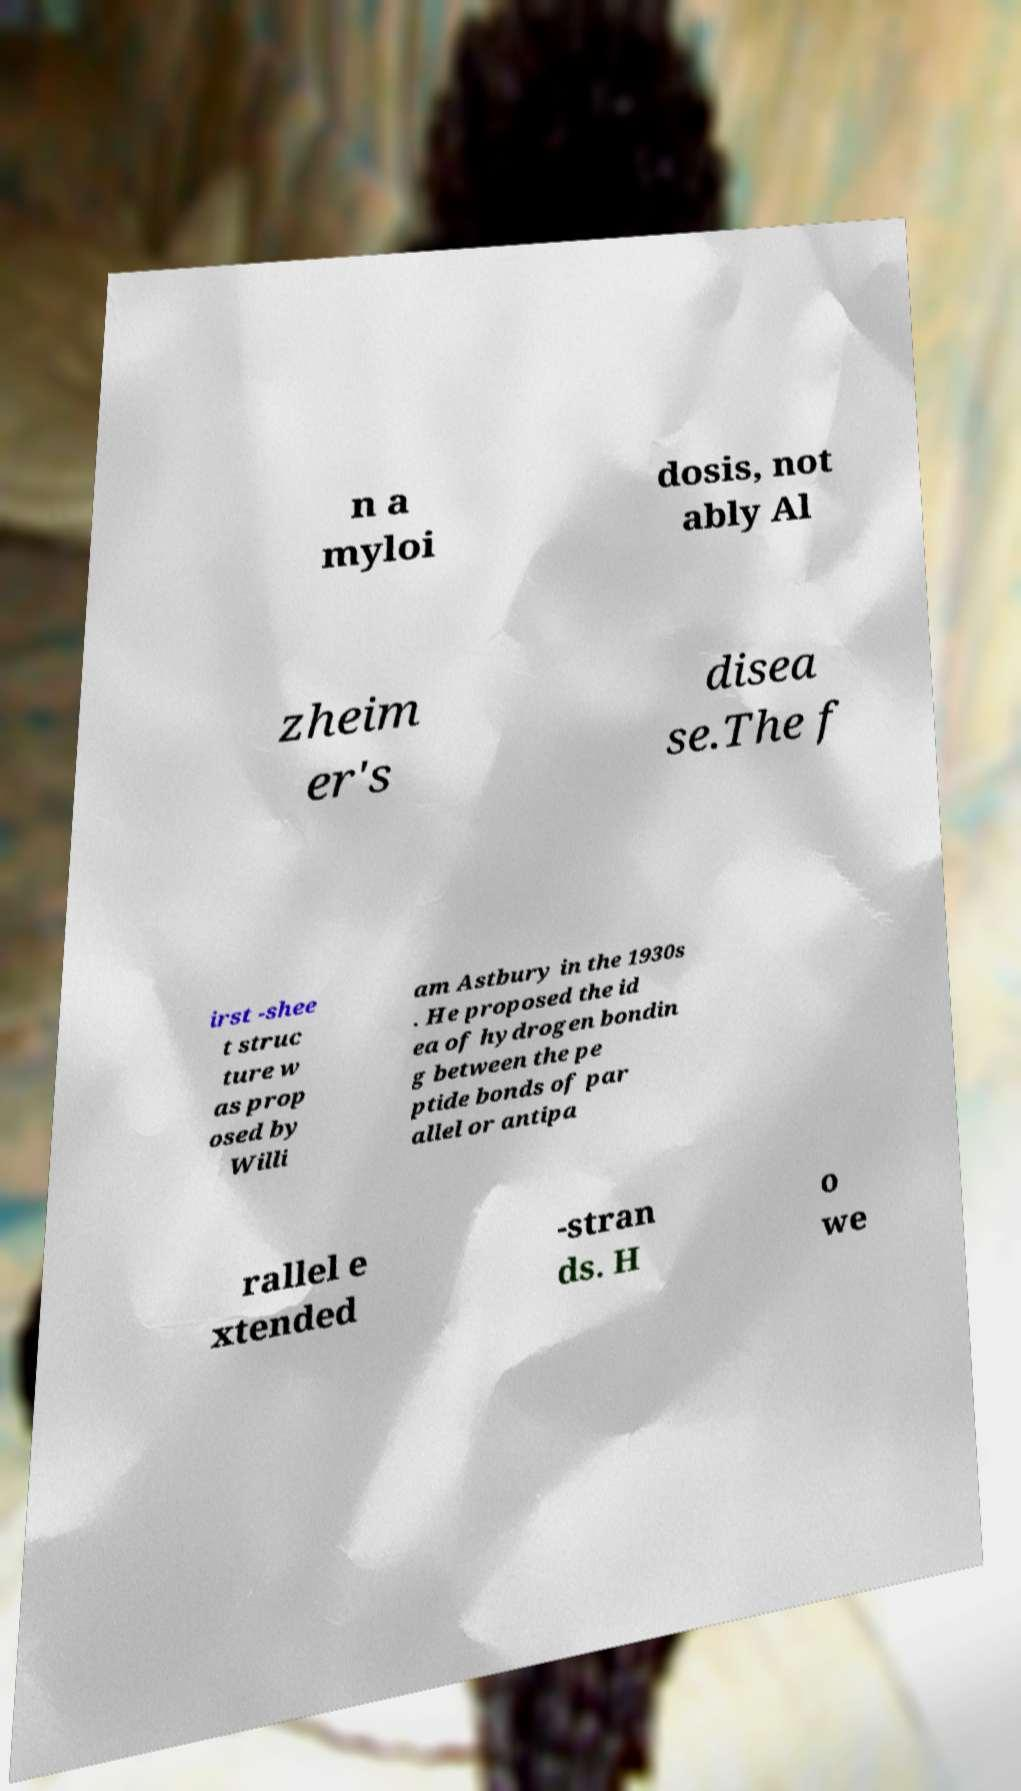Could you extract and type out the text from this image? n a myloi dosis, not ably Al zheim er's disea se.The f irst -shee t struc ture w as prop osed by Willi am Astbury in the 1930s . He proposed the id ea of hydrogen bondin g between the pe ptide bonds of par allel or antipa rallel e xtended -stran ds. H o we 